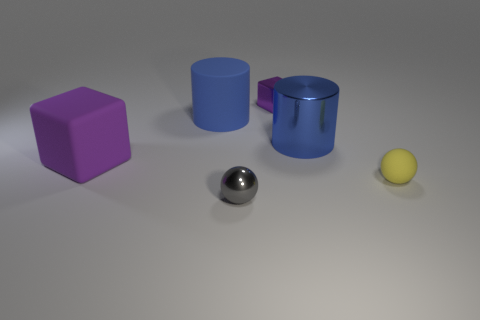Add 1 small red metal spheres. How many objects exist? 7 Subtract all cubes. How many objects are left? 4 Subtract all tiny gray balls. Subtract all blocks. How many objects are left? 3 Add 4 small metallic objects. How many small metallic objects are left? 6 Add 6 blue matte things. How many blue matte things exist? 7 Subtract 0 red cylinders. How many objects are left? 6 